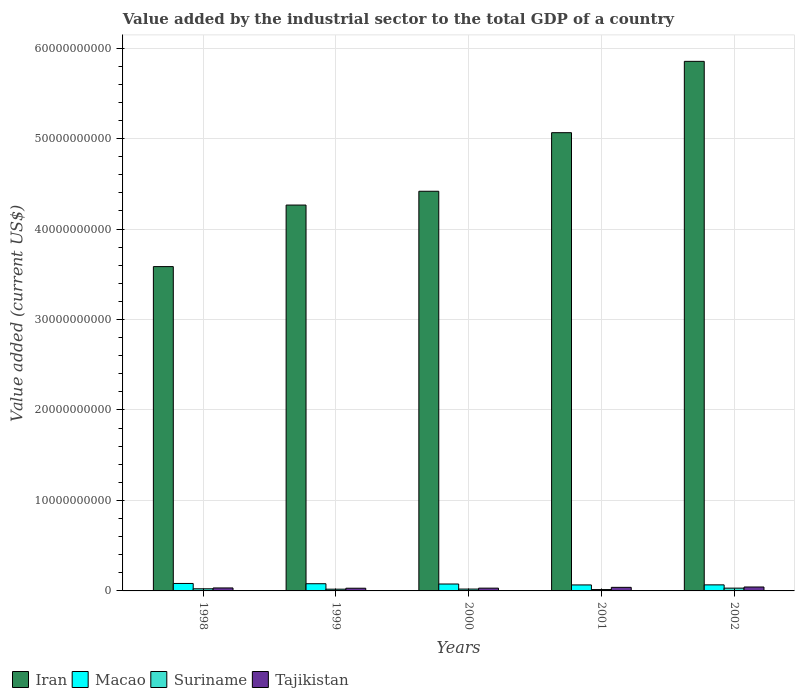Are the number of bars per tick equal to the number of legend labels?
Offer a terse response. Yes. Are the number of bars on each tick of the X-axis equal?
Offer a terse response. Yes. What is the label of the 4th group of bars from the left?
Offer a very short reply. 2001. What is the value added by the industrial sector to the total GDP in Iran in 1998?
Keep it short and to the point. 3.58e+1. Across all years, what is the maximum value added by the industrial sector to the total GDP in Tajikistan?
Provide a short and direct response. 4.34e+08. Across all years, what is the minimum value added by the industrial sector to the total GDP in Iran?
Offer a very short reply. 3.58e+1. In which year was the value added by the industrial sector to the total GDP in Iran minimum?
Give a very brief answer. 1998. What is the total value added by the industrial sector to the total GDP in Suriname in the graph?
Ensure brevity in your answer.  1.09e+09. What is the difference between the value added by the industrial sector to the total GDP in Macao in 1998 and that in 2002?
Offer a terse response. 1.56e+08. What is the difference between the value added by the industrial sector to the total GDP in Tajikistan in 2000 and the value added by the industrial sector to the total GDP in Iran in 2001?
Ensure brevity in your answer.  -5.03e+1. What is the average value added by the industrial sector to the total GDP in Suriname per year?
Keep it short and to the point. 2.18e+08. In the year 1999, what is the difference between the value added by the industrial sector to the total GDP in Suriname and value added by the industrial sector to the total GDP in Macao?
Offer a terse response. -6.01e+08. What is the ratio of the value added by the industrial sector to the total GDP in Macao in 2000 to that in 2001?
Ensure brevity in your answer.  1.15. Is the difference between the value added by the industrial sector to the total GDP in Suriname in 2001 and 2002 greater than the difference between the value added by the industrial sector to the total GDP in Macao in 2001 and 2002?
Provide a short and direct response. No. What is the difference between the highest and the second highest value added by the industrial sector to the total GDP in Suriname?
Your answer should be compact. 7.19e+07. What is the difference between the highest and the lowest value added by the industrial sector to the total GDP in Tajikistan?
Your answer should be very brief. 1.36e+08. Is it the case that in every year, the sum of the value added by the industrial sector to the total GDP in Tajikistan and value added by the industrial sector to the total GDP in Macao is greater than the sum of value added by the industrial sector to the total GDP in Suriname and value added by the industrial sector to the total GDP in Iran?
Give a very brief answer. No. What does the 2nd bar from the left in 2002 represents?
Make the answer very short. Macao. What does the 1st bar from the right in 2000 represents?
Ensure brevity in your answer.  Tajikistan. Is it the case that in every year, the sum of the value added by the industrial sector to the total GDP in Suriname and value added by the industrial sector to the total GDP in Macao is greater than the value added by the industrial sector to the total GDP in Tajikistan?
Your answer should be very brief. Yes. How many legend labels are there?
Ensure brevity in your answer.  4. What is the title of the graph?
Make the answer very short. Value added by the industrial sector to the total GDP of a country. What is the label or title of the Y-axis?
Your answer should be very brief. Value added (current US$). What is the Value added (current US$) in Iran in 1998?
Make the answer very short. 3.58e+1. What is the Value added (current US$) of Macao in 1998?
Provide a succinct answer. 8.25e+08. What is the Value added (current US$) in Suriname in 1998?
Your response must be concise. 2.36e+08. What is the Value added (current US$) of Tajikistan in 1998?
Keep it short and to the point. 3.29e+08. What is the Value added (current US$) in Iran in 1999?
Give a very brief answer. 4.26e+1. What is the Value added (current US$) in Macao in 1999?
Your response must be concise. 7.94e+08. What is the Value added (current US$) in Suriname in 1999?
Make the answer very short. 1.93e+08. What is the Value added (current US$) in Tajikistan in 1999?
Provide a succinct answer. 2.98e+08. What is the Value added (current US$) of Iran in 2000?
Ensure brevity in your answer.  4.42e+1. What is the Value added (current US$) in Macao in 2000?
Provide a succinct answer. 7.64e+08. What is the Value added (current US$) in Suriname in 2000?
Offer a terse response. 2.04e+08. What is the Value added (current US$) of Tajikistan in 2000?
Offer a terse response. 3.06e+08. What is the Value added (current US$) in Iran in 2001?
Provide a succinct answer. 5.06e+1. What is the Value added (current US$) in Macao in 2001?
Provide a short and direct response. 6.62e+08. What is the Value added (current US$) of Suriname in 2001?
Your answer should be compact. 1.50e+08. What is the Value added (current US$) in Tajikistan in 2001?
Make the answer very short. 3.94e+08. What is the Value added (current US$) in Iran in 2002?
Give a very brief answer. 5.85e+1. What is the Value added (current US$) in Macao in 2002?
Provide a short and direct response. 6.69e+08. What is the Value added (current US$) in Suriname in 2002?
Offer a terse response. 3.08e+08. What is the Value added (current US$) of Tajikistan in 2002?
Provide a short and direct response. 4.34e+08. Across all years, what is the maximum Value added (current US$) of Iran?
Your response must be concise. 5.85e+1. Across all years, what is the maximum Value added (current US$) of Macao?
Provide a succinct answer. 8.25e+08. Across all years, what is the maximum Value added (current US$) of Suriname?
Keep it short and to the point. 3.08e+08. Across all years, what is the maximum Value added (current US$) in Tajikistan?
Offer a terse response. 4.34e+08. Across all years, what is the minimum Value added (current US$) in Iran?
Your response must be concise. 3.58e+1. Across all years, what is the minimum Value added (current US$) in Macao?
Make the answer very short. 6.62e+08. Across all years, what is the minimum Value added (current US$) of Suriname?
Your response must be concise. 1.50e+08. Across all years, what is the minimum Value added (current US$) of Tajikistan?
Your response must be concise. 2.98e+08. What is the total Value added (current US$) in Iran in the graph?
Your answer should be compact. 2.32e+11. What is the total Value added (current US$) in Macao in the graph?
Your answer should be very brief. 3.71e+09. What is the total Value added (current US$) in Suriname in the graph?
Give a very brief answer. 1.09e+09. What is the total Value added (current US$) of Tajikistan in the graph?
Ensure brevity in your answer.  1.76e+09. What is the difference between the Value added (current US$) in Iran in 1998 and that in 1999?
Give a very brief answer. -6.80e+09. What is the difference between the Value added (current US$) of Macao in 1998 and that in 1999?
Your answer should be compact. 3.06e+07. What is the difference between the Value added (current US$) of Suriname in 1998 and that in 1999?
Your answer should be very brief. 4.29e+07. What is the difference between the Value added (current US$) in Tajikistan in 1998 and that in 1999?
Ensure brevity in your answer.  3.11e+07. What is the difference between the Value added (current US$) of Iran in 1998 and that in 2000?
Give a very brief answer. -8.33e+09. What is the difference between the Value added (current US$) of Macao in 1998 and that in 2000?
Keep it short and to the point. 6.14e+07. What is the difference between the Value added (current US$) in Suriname in 1998 and that in 2000?
Keep it short and to the point. 3.18e+07. What is the difference between the Value added (current US$) of Tajikistan in 1998 and that in 2000?
Give a very brief answer. 2.31e+07. What is the difference between the Value added (current US$) in Iran in 1998 and that in 2001?
Provide a short and direct response. -1.48e+1. What is the difference between the Value added (current US$) in Macao in 1998 and that in 2001?
Provide a short and direct response. 1.63e+08. What is the difference between the Value added (current US$) in Suriname in 1998 and that in 2001?
Your response must be concise. 8.63e+07. What is the difference between the Value added (current US$) in Tajikistan in 1998 and that in 2001?
Provide a short and direct response. -6.48e+07. What is the difference between the Value added (current US$) in Iran in 1998 and that in 2002?
Your answer should be compact. -2.27e+1. What is the difference between the Value added (current US$) in Macao in 1998 and that in 2002?
Your response must be concise. 1.56e+08. What is the difference between the Value added (current US$) in Suriname in 1998 and that in 2002?
Give a very brief answer. -7.19e+07. What is the difference between the Value added (current US$) in Tajikistan in 1998 and that in 2002?
Offer a very short reply. -1.05e+08. What is the difference between the Value added (current US$) of Iran in 1999 and that in 2000?
Ensure brevity in your answer.  -1.53e+09. What is the difference between the Value added (current US$) in Macao in 1999 and that in 2000?
Keep it short and to the point. 3.08e+07. What is the difference between the Value added (current US$) in Suriname in 1999 and that in 2000?
Offer a terse response. -1.11e+07. What is the difference between the Value added (current US$) of Tajikistan in 1999 and that in 2000?
Ensure brevity in your answer.  -7.97e+06. What is the difference between the Value added (current US$) in Iran in 1999 and that in 2001?
Make the answer very short. -8.00e+09. What is the difference between the Value added (current US$) in Macao in 1999 and that in 2001?
Give a very brief answer. 1.32e+08. What is the difference between the Value added (current US$) in Suriname in 1999 and that in 2001?
Provide a succinct answer. 4.35e+07. What is the difference between the Value added (current US$) in Tajikistan in 1999 and that in 2001?
Your response must be concise. -9.58e+07. What is the difference between the Value added (current US$) of Iran in 1999 and that in 2002?
Keep it short and to the point. -1.59e+1. What is the difference between the Value added (current US$) in Macao in 1999 and that in 2002?
Make the answer very short. 1.26e+08. What is the difference between the Value added (current US$) of Suriname in 1999 and that in 2002?
Give a very brief answer. -1.15e+08. What is the difference between the Value added (current US$) of Tajikistan in 1999 and that in 2002?
Your answer should be compact. -1.36e+08. What is the difference between the Value added (current US$) of Iran in 2000 and that in 2001?
Your response must be concise. -6.47e+09. What is the difference between the Value added (current US$) of Macao in 2000 and that in 2001?
Make the answer very short. 1.02e+08. What is the difference between the Value added (current US$) in Suriname in 2000 and that in 2001?
Your answer should be compact. 5.45e+07. What is the difference between the Value added (current US$) in Tajikistan in 2000 and that in 2001?
Provide a short and direct response. -8.79e+07. What is the difference between the Value added (current US$) in Iran in 2000 and that in 2002?
Your answer should be compact. -1.44e+1. What is the difference between the Value added (current US$) in Macao in 2000 and that in 2002?
Your answer should be compact. 9.51e+07. What is the difference between the Value added (current US$) in Suriname in 2000 and that in 2002?
Offer a terse response. -1.04e+08. What is the difference between the Value added (current US$) of Tajikistan in 2000 and that in 2002?
Give a very brief answer. -1.28e+08. What is the difference between the Value added (current US$) of Iran in 2001 and that in 2002?
Ensure brevity in your answer.  -7.88e+09. What is the difference between the Value added (current US$) in Macao in 2001 and that in 2002?
Provide a short and direct response. -6.62e+06. What is the difference between the Value added (current US$) in Suriname in 2001 and that in 2002?
Your response must be concise. -1.58e+08. What is the difference between the Value added (current US$) in Tajikistan in 2001 and that in 2002?
Make the answer very short. -3.98e+07. What is the difference between the Value added (current US$) in Iran in 1998 and the Value added (current US$) in Macao in 1999?
Your response must be concise. 3.50e+1. What is the difference between the Value added (current US$) in Iran in 1998 and the Value added (current US$) in Suriname in 1999?
Offer a very short reply. 3.57e+1. What is the difference between the Value added (current US$) of Iran in 1998 and the Value added (current US$) of Tajikistan in 1999?
Your answer should be compact. 3.55e+1. What is the difference between the Value added (current US$) of Macao in 1998 and the Value added (current US$) of Suriname in 1999?
Keep it short and to the point. 6.32e+08. What is the difference between the Value added (current US$) in Macao in 1998 and the Value added (current US$) in Tajikistan in 1999?
Offer a terse response. 5.27e+08. What is the difference between the Value added (current US$) in Suriname in 1998 and the Value added (current US$) in Tajikistan in 1999?
Offer a terse response. -6.23e+07. What is the difference between the Value added (current US$) in Iran in 1998 and the Value added (current US$) in Macao in 2000?
Make the answer very short. 3.51e+1. What is the difference between the Value added (current US$) in Iran in 1998 and the Value added (current US$) in Suriname in 2000?
Your answer should be compact. 3.56e+1. What is the difference between the Value added (current US$) in Iran in 1998 and the Value added (current US$) in Tajikistan in 2000?
Provide a short and direct response. 3.55e+1. What is the difference between the Value added (current US$) in Macao in 1998 and the Value added (current US$) in Suriname in 2000?
Ensure brevity in your answer.  6.21e+08. What is the difference between the Value added (current US$) of Macao in 1998 and the Value added (current US$) of Tajikistan in 2000?
Ensure brevity in your answer.  5.19e+08. What is the difference between the Value added (current US$) of Suriname in 1998 and the Value added (current US$) of Tajikistan in 2000?
Ensure brevity in your answer.  -7.02e+07. What is the difference between the Value added (current US$) in Iran in 1998 and the Value added (current US$) in Macao in 2001?
Offer a terse response. 3.52e+1. What is the difference between the Value added (current US$) in Iran in 1998 and the Value added (current US$) in Suriname in 2001?
Offer a terse response. 3.57e+1. What is the difference between the Value added (current US$) of Iran in 1998 and the Value added (current US$) of Tajikistan in 2001?
Ensure brevity in your answer.  3.54e+1. What is the difference between the Value added (current US$) of Macao in 1998 and the Value added (current US$) of Suriname in 2001?
Make the answer very short. 6.75e+08. What is the difference between the Value added (current US$) in Macao in 1998 and the Value added (current US$) in Tajikistan in 2001?
Provide a short and direct response. 4.31e+08. What is the difference between the Value added (current US$) in Suriname in 1998 and the Value added (current US$) in Tajikistan in 2001?
Offer a terse response. -1.58e+08. What is the difference between the Value added (current US$) in Iran in 1998 and the Value added (current US$) in Macao in 2002?
Ensure brevity in your answer.  3.52e+1. What is the difference between the Value added (current US$) in Iran in 1998 and the Value added (current US$) in Suriname in 2002?
Provide a short and direct response. 3.55e+1. What is the difference between the Value added (current US$) in Iran in 1998 and the Value added (current US$) in Tajikistan in 2002?
Your response must be concise. 3.54e+1. What is the difference between the Value added (current US$) in Macao in 1998 and the Value added (current US$) in Suriname in 2002?
Offer a very short reply. 5.17e+08. What is the difference between the Value added (current US$) in Macao in 1998 and the Value added (current US$) in Tajikistan in 2002?
Ensure brevity in your answer.  3.91e+08. What is the difference between the Value added (current US$) in Suriname in 1998 and the Value added (current US$) in Tajikistan in 2002?
Your answer should be very brief. -1.98e+08. What is the difference between the Value added (current US$) in Iran in 1999 and the Value added (current US$) in Macao in 2000?
Your answer should be compact. 4.19e+1. What is the difference between the Value added (current US$) of Iran in 1999 and the Value added (current US$) of Suriname in 2000?
Make the answer very short. 4.24e+1. What is the difference between the Value added (current US$) of Iran in 1999 and the Value added (current US$) of Tajikistan in 2000?
Your answer should be very brief. 4.23e+1. What is the difference between the Value added (current US$) of Macao in 1999 and the Value added (current US$) of Suriname in 2000?
Keep it short and to the point. 5.90e+08. What is the difference between the Value added (current US$) of Macao in 1999 and the Value added (current US$) of Tajikistan in 2000?
Your answer should be very brief. 4.88e+08. What is the difference between the Value added (current US$) in Suriname in 1999 and the Value added (current US$) in Tajikistan in 2000?
Provide a short and direct response. -1.13e+08. What is the difference between the Value added (current US$) in Iran in 1999 and the Value added (current US$) in Macao in 2001?
Give a very brief answer. 4.20e+1. What is the difference between the Value added (current US$) in Iran in 1999 and the Value added (current US$) in Suriname in 2001?
Give a very brief answer. 4.25e+1. What is the difference between the Value added (current US$) in Iran in 1999 and the Value added (current US$) in Tajikistan in 2001?
Provide a short and direct response. 4.23e+1. What is the difference between the Value added (current US$) in Macao in 1999 and the Value added (current US$) in Suriname in 2001?
Give a very brief answer. 6.45e+08. What is the difference between the Value added (current US$) in Macao in 1999 and the Value added (current US$) in Tajikistan in 2001?
Provide a succinct answer. 4.00e+08. What is the difference between the Value added (current US$) in Suriname in 1999 and the Value added (current US$) in Tajikistan in 2001?
Ensure brevity in your answer.  -2.01e+08. What is the difference between the Value added (current US$) in Iran in 1999 and the Value added (current US$) in Macao in 2002?
Offer a very short reply. 4.20e+1. What is the difference between the Value added (current US$) in Iran in 1999 and the Value added (current US$) in Suriname in 2002?
Offer a very short reply. 4.23e+1. What is the difference between the Value added (current US$) in Iran in 1999 and the Value added (current US$) in Tajikistan in 2002?
Your answer should be compact. 4.22e+1. What is the difference between the Value added (current US$) of Macao in 1999 and the Value added (current US$) of Suriname in 2002?
Ensure brevity in your answer.  4.86e+08. What is the difference between the Value added (current US$) of Macao in 1999 and the Value added (current US$) of Tajikistan in 2002?
Ensure brevity in your answer.  3.60e+08. What is the difference between the Value added (current US$) of Suriname in 1999 and the Value added (current US$) of Tajikistan in 2002?
Your answer should be very brief. -2.41e+08. What is the difference between the Value added (current US$) in Iran in 2000 and the Value added (current US$) in Macao in 2001?
Ensure brevity in your answer.  4.35e+1. What is the difference between the Value added (current US$) in Iran in 2000 and the Value added (current US$) in Suriname in 2001?
Your response must be concise. 4.40e+1. What is the difference between the Value added (current US$) of Iran in 2000 and the Value added (current US$) of Tajikistan in 2001?
Offer a very short reply. 4.38e+1. What is the difference between the Value added (current US$) in Macao in 2000 and the Value added (current US$) in Suriname in 2001?
Ensure brevity in your answer.  6.14e+08. What is the difference between the Value added (current US$) of Macao in 2000 and the Value added (current US$) of Tajikistan in 2001?
Your answer should be compact. 3.69e+08. What is the difference between the Value added (current US$) in Suriname in 2000 and the Value added (current US$) in Tajikistan in 2001?
Offer a terse response. -1.90e+08. What is the difference between the Value added (current US$) of Iran in 2000 and the Value added (current US$) of Macao in 2002?
Your answer should be very brief. 4.35e+1. What is the difference between the Value added (current US$) of Iran in 2000 and the Value added (current US$) of Suriname in 2002?
Give a very brief answer. 4.39e+1. What is the difference between the Value added (current US$) in Iran in 2000 and the Value added (current US$) in Tajikistan in 2002?
Keep it short and to the point. 4.37e+1. What is the difference between the Value added (current US$) in Macao in 2000 and the Value added (current US$) in Suriname in 2002?
Offer a very short reply. 4.56e+08. What is the difference between the Value added (current US$) in Macao in 2000 and the Value added (current US$) in Tajikistan in 2002?
Provide a succinct answer. 3.30e+08. What is the difference between the Value added (current US$) in Suriname in 2000 and the Value added (current US$) in Tajikistan in 2002?
Offer a very short reply. -2.30e+08. What is the difference between the Value added (current US$) of Iran in 2001 and the Value added (current US$) of Macao in 2002?
Offer a very short reply. 5.00e+1. What is the difference between the Value added (current US$) of Iran in 2001 and the Value added (current US$) of Suriname in 2002?
Your answer should be very brief. 5.03e+1. What is the difference between the Value added (current US$) of Iran in 2001 and the Value added (current US$) of Tajikistan in 2002?
Offer a terse response. 5.02e+1. What is the difference between the Value added (current US$) in Macao in 2001 and the Value added (current US$) in Suriname in 2002?
Provide a succinct answer. 3.54e+08. What is the difference between the Value added (current US$) of Macao in 2001 and the Value added (current US$) of Tajikistan in 2002?
Offer a very short reply. 2.28e+08. What is the difference between the Value added (current US$) of Suriname in 2001 and the Value added (current US$) of Tajikistan in 2002?
Provide a short and direct response. -2.84e+08. What is the average Value added (current US$) of Iran per year?
Your response must be concise. 4.64e+1. What is the average Value added (current US$) of Macao per year?
Your answer should be very brief. 7.43e+08. What is the average Value added (current US$) of Suriname per year?
Keep it short and to the point. 2.18e+08. What is the average Value added (current US$) in Tajikistan per year?
Keep it short and to the point. 3.52e+08. In the year 1998, what is the difference between the Value added (current US$) in Iran and Value added (current US$) in Macao?
Give a very brief answer. 3.50e+1. In the year 1998, what is the difference between the Value added (current US$) of Iran and Value added (current US$) of Suriname?
Give a very brief answer. 3.56e+1. In the year 1998, what is the difference between the Value added (current US$) in Iran and Value added (current US$) in Tajikistan?
Ensure brevity in your answer.  3.55e+1. In the year 1998, what is the difference between the Value added (current US$) in Macao and Value added (current US$) in Suriname?
Provide a succinct answer. 5.89e+08. In the year 1998, what is the difference between the Value added (current US$) in Macao and Value added (current US$) in Tajikistan?
Your response must be concise. 4.96e+08. In the year 1998, what is the difference between the Value added (current US$) in Suriname and Value added (current US$) in Tajikistan?
Ensure brevity in your answer.  -9.33e+07. In the year 1999, what is the difference between the Value added (current US$) in Iran and Value added (current US$) in Macao?
Ensure brevity in your answer.  4.19e+1. In the year 1999, what is the difference between the Value added (current US$) of Iran and Value added (current US$) of Suriname?
Your response must be concise. 4.25e+1. In the year 1999, what is the difference between the Value added (current US$) of Iran and Value added (current US$) of Tajikistan?
Offer a terse response. 4.23e+1. In the year 1999, what is the difference between the Value added (current US$) in Macao and Value added (current US$) in Suriname?
Keep it short and to the point. 6.01e+08. In the year 1999, what is the difference between the Value added (current US$) of Macao and Value added (current US$) of Tajikistan?
Your response must be concise. 4.96e+08. In the year 1999, what is the difference between the Value added (current US$) in Suriname and Value added (current US$) in Tajikistan?
Your answer should be compact. -1.05e+08. In the year 2000, what is the difference between the Value added (current US$) of Iran and Value added (current US$) of Macao?
Your answer should be compact. 4.34e+1. In the year 2000, what is the difference between the Value added (current US$) in Iran and Value added (current US$) in Suriname?
Provide a short and direct response. 4.40e+1. In the year 2000, what is the difference between the Value added (current US$) in Iran and Value added (current US$) in Tajikistan?
Your response must be concise. 4.39e+1. In the year 2000, what is the difference between the Value added (current US$) of Macao and Value added (current US$) of Suriname?
Your answer should be very brief. 5.59e+08. In the year 2000, what is the difference between the Value added (current US$) in Macao and Value added (current US$) in Tajikistan?
Ensure brevity in your answer.  4.57e+08. In the year 2000, what is the difference between the Value added (current US$) of Suriname and Value added (current US$) of Tajikistan?
Keep it short and to the point. -1.02e+08. In the year 2001, what is the difference between the Value added (current US$) of Iran and Value added (current US$) of Macao?
Offer a very short reply. 5.00e+1. In the year 2001, what is the difference between the Value added (current US$) in Iran and Value added (current US$) in Suriname?
Keep it short and to the point. 5.05e+1. In the year 2001, what is the difference between the Value added (current US$) of Iran and Value added (current US$) of Tajikistan?
Your response must be concise. 5.03e+1. In the year 2001, what is the difference between the Value added (current US$) of Macao and Value added (current US$) of Suriname?
Keep it short and to the point. 5.12e+08. In the year 2001, what is the difference between the Value added (current US$) of Macao and Value added (current US$) of Tajikistan?
Make the answer very short. 2.68e+08. In the year 2001, what is the difference between the Value added (current US$) of Suriname and Value added (current US$) of Tajikistan?
Your answer should be compact. -2.44e+08. In the year 2002, what is the difference between the Value added (current US$) of Iran and Value added (current US$) of Macao?
Your answer should be very brief. 5.79e+1. In the year 2002, what is the difference between the Value added (current US$) in Iran and Value added (current US$) in Suriname?
Ensure brevity in your answer.  5.82e+1. In the year 2002, what is the difference between the Value added (current US$) in Iran and Value added (current US$) in Tajikistan?
Provide a succinct answer. 5.81e+1. In the year 2002, what is the difference between the Value added (current US$) of Macao and Value added (current US$) of Suriname?
Your answer should be very brief. 3.61e+08. In the year 2002, what is the difference between the Value added (current US$) in Macao and Value added (current US$) in Tajikistan?
Provide a succinct answer. 2.35e+08. In the year 2002, what is the difference between the Value added (current US$) of Suriname and Value added (current US$) of Tajikistan?
Your answer should be compact. -1.26e+08. What is the ratio of the Value added (current US$) of Iran in 1998 to that in 1999?
Your response must be concise. 0.84. What is the ratio of the Value added (current US$) of Suriname in 1998 to that in 1999?
Your response must be concise. 1.22. What is the ratio of the Value added (current US$) of Tajikistan in 1998 to that in 1999?
Your response must be concise. 1.1. What is the ratio of the Value added (current US$) of Iran in 1998 to that in 2000?
Your answer should be very brief. 0.81. What is the ratio of the Value added (current US$) of Macao in 1998 to that in 2000?
Your answer should be very brief. 1.08. What is the ratio of the Value added (current US$) in Suriname in 1998 to that in 2000?
Provide a short and direct response. 1.16. What is the ratio of the Value added (current US$) of Tajikistan in 1998 to that in 2000?
Offer a terse response. 1.08. What is the ratio of the Value added (current US$) of Iran in 1998 to that in 2001?
Ensure brevity in your answer.  0.71. What is the ratio of the Value added (current US$) in Macao in 1998 to that in 2001?
Offer a very short reply. 1.25. What is the ratio of the Value added (current US$) in Suriname in 1998 to that in 2001?
Make the answer very short. 1.58. What is the ratio of the Value added (current US$) in Tajikistan in 1998 to that in 2001?
Offer a very short reply. 0.84. What is the ratio of the Value added (current US$) of Iran in 1998 to that in 2002?
Provide a succinct answer. 0.61. What is the ratio of the Value added (current US$) of Macao in 1998 to that in 2002?
Provide a short and direct response. 1.23. What is the ratio of the Value added (current US$) of Suriname in 1998 to that in 2002?
Your answer should be very brief. 0.77. What is the ratio of the Value added (current US$) of Tajikistan in 1998 to that in 2002?
Your answer should be very brief. 0.76. What is the ratio of the Value added (current US$) in Iran in 1999 to that in 2000?
Give a very brief answer. 0.97. What is the ratio of the Value added (current US$) of Macao in 1999 to that in 2000?
Keep it short and to the point. 1.04. What is the ratio of the Value added (current US$) in Suriname in 1999 to that in 2000?
Offer a very short reply. 0.95. What is the ratio of the Value added (current US$) in Iran in 1999 to that in 2001?
Offer a very short reply. 0.84. What is the ratio of the Value added (current US$) of Macao in 1999 to that in 2001?
Provide a short and direct response. 1.2. What is the ratio of the Value added (current US$) in Suriname in 1999 to that in 2001?
Offer a very short reply. 1.29. What is the ratio of the Value added (current US$) of Tajikistan in 1999 to that in 2001?
Provide a succinct answer. 0.76. What is the ratio of the Value added (current US$) of Iran in 1999 to that in 2002?
Offer a very short reply. 0.73. What is the ratio of the Value added (current US$) of Macao in 1999 to that in 2002?
Your answer should be compact. 1.19. What is the ratio of the Value added (current US$) in Suriname in 1999 to that in 2002?
Give a very brief answer. 0.63. What is the ratio of the Value added (current US$) of Tajikistan in 1999 to that in 2002?
Offer a very short reply. 0.69. What is the ratio of the Value added (current US$) of Iran in 2000 to that in 2001?
Your answer should be very brief. 0.87. What is the ratio of the Value added (current US$) in Macao in 2000 to that in 2001?
Provide a short and direct response. 1.15. What is the ratio of the Value added (current US$) of Suriname in 2000 to that in 2001?
Keep it short and to the point. 1.36. What is the ratio of the Value added (current US$) in Tajikistan in 2000 to that in 2001?
Your answer should be very brief. 0.78. What is the ratio of the Value added (current US$) of Iran in 2000 to that in 2002?
Offer a terse response. 0.75. What is the ratio of the Value added (current US$) in Macao in 2000 to that in 2002?
Offer a very short reply. 1.14. What is the ratio of the Value added (current US$) of Suriname in 2000 to that in 2002?
Give a very brief answer. 0.66. What is the ratio of the Value added (current US$) of Tajikistan in 2000 to that in 2002?
Your answer should be compact. 0.71. What is the ratio of the Value added (current US$) of Iran in 2001 to that in 2002?
Provide a succinct answer. 0.87. What is the ratio of the Value added (current US$) of Suriname in 2001 to that in 2002?
Provide a succinct answer. 0.49. What is the ratio of the Value added (current US$) in Tajikistan in 2001 to that in 2002?
Provide a short and direct response. 0.91. What is the difference between the highest and the second highest Value added (current US$) of Iran?
Your answer should be compact. 7.88e+09. What is the difference between the highest and the second highest Value added (current US$) in Macao?
Offer a terse response. 3.06e+07. What is the difference between the highest and the second highest Value added (current US$) of Suriname?
Keep it short and to the point. 7.19e+07. What is the difference between the highest and the second highest Value added (current US$) of Tajikistan?
Provide a short and direct response. 3.98e+07. What is the difference between the highest and the lowest Value added (current US$) of Iran?
Give a very brief answer. 2.27e+1. What is the difference between the highest and the lowest Value added (current US$) of Macao?
Your answer should be very brief. 1.63e+08. What is the difference between the highest and the lowest Value added (current US$) in Suriname?
Offer a terse response. 1.58e+08. What is the difference between the highest and the lowest Value added (current US$) in Tajikistan?
Your response must be concise. 1.36e+08. 